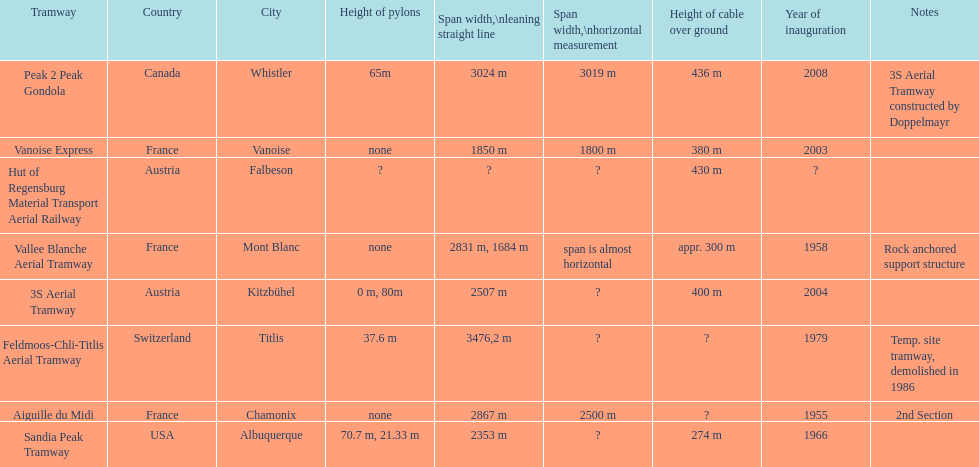How many aerial tramways are located in france? 3. 